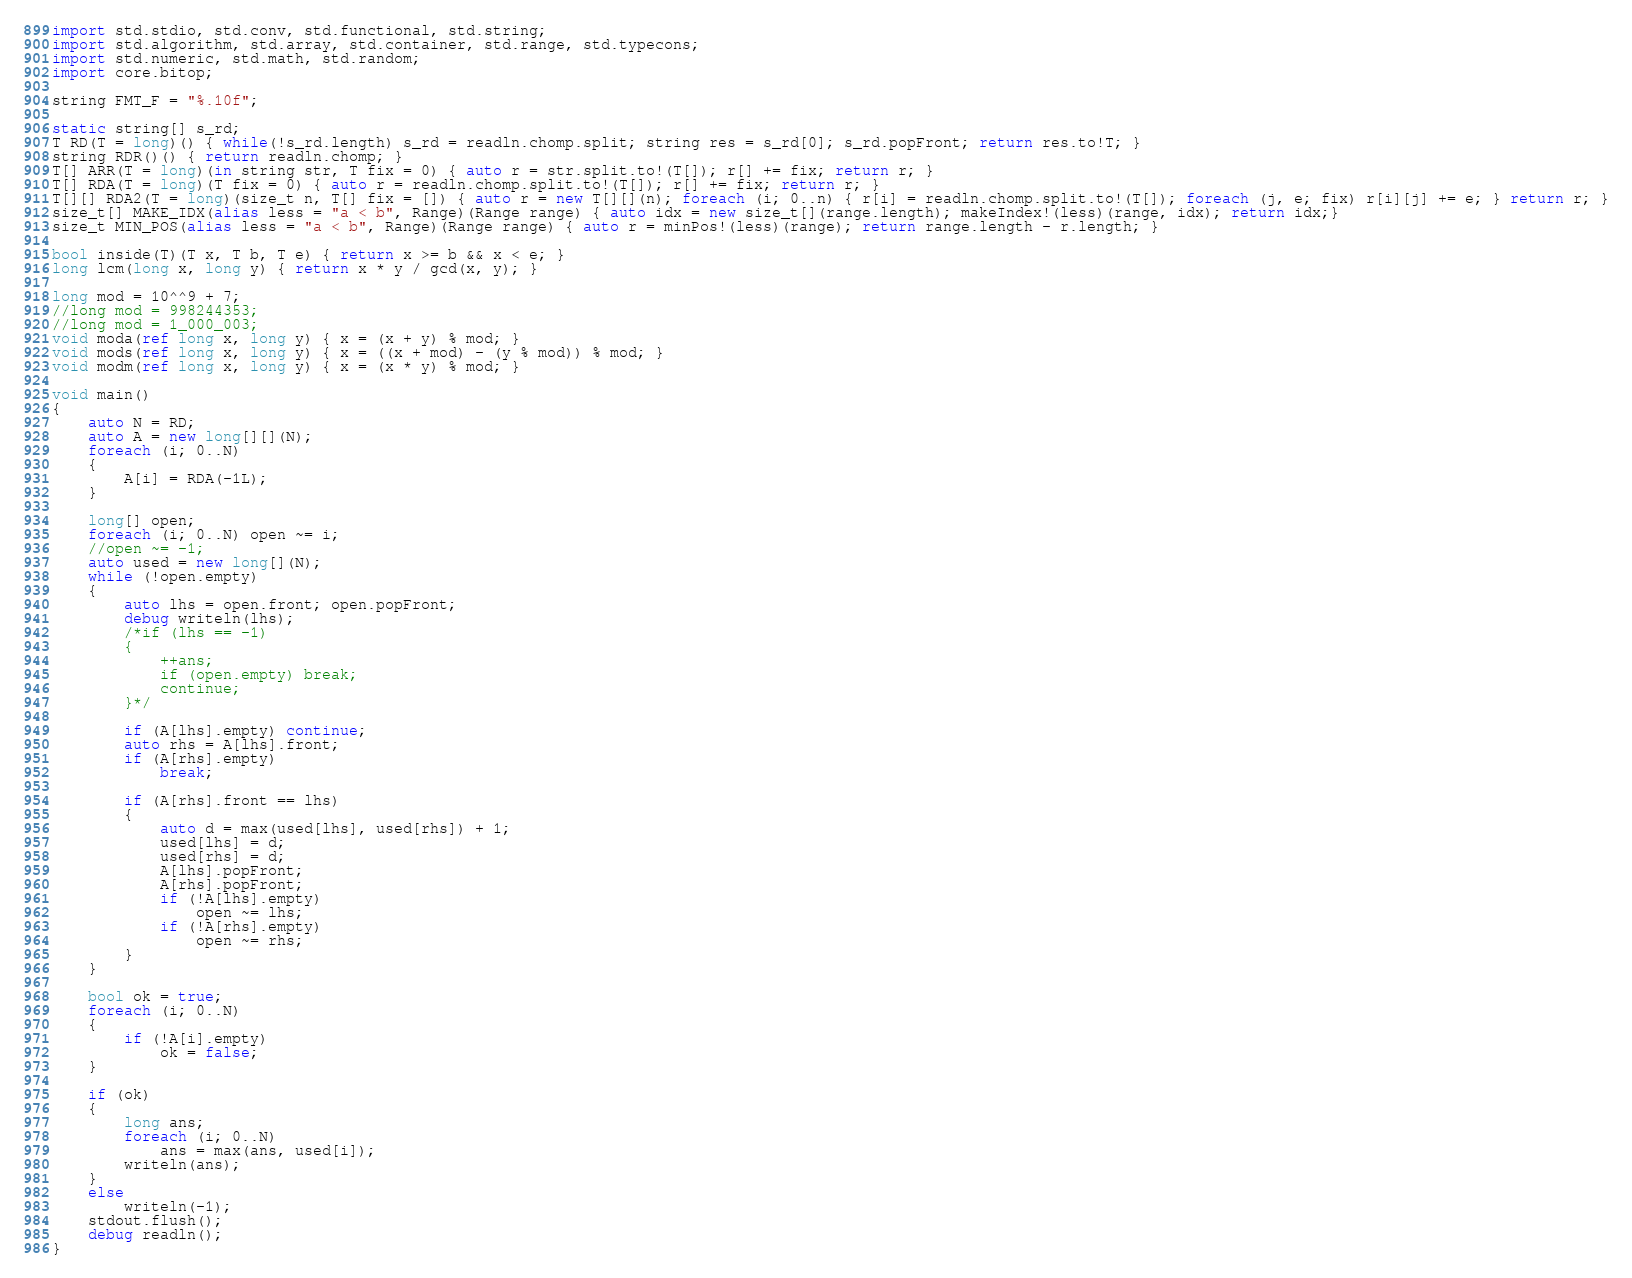<code> <loc_0><loc_0><loc_500><loc_500><_D_>import std.stdio, std.conv, std.functional, std.string;
import std.algorithm, std.array, std.container, std.range, std.typecons;
import std.numeric, std.math, std.random;
import core.bitop;

string FMT_F = "%.10f";

static string[] s_rd;
T RD(T = long)() { while(!s_rd.length) s_rd = readln.chomp.split; string res = s_rd[0]; s_rd.popFront; return res.to!T; }
string RDR()() { return readln.chomp; }
T[] ARR(T = long)(in string str, T fix = 0) { auto r = str.split.to!(T[]); r[] += fix; return r; }
T[] RDA(T = long)(T fix = 0) { auto r = readln.chomp.split.to!(T[]); r[] += fix; return r; }
T[][] RDA2(T = long)(size_t n, T[] fix = []) { auto r = new T[][](n); foreach (i; 0..n) { r[i] = readln.chomp.split.to!(T[]); foreach (j, e; fix) r[i][j] += e; } return r; }
size_t[] MAKE_IDX(alias less = "a < b", Range)(Range range) { auto idx = new size_t[](range.length); makeIndex!(less)(range, idx); return idx;}
size_t MIN_POS(alias less = "a < b", Range)(Range range) { auto r = minPos!(less)(range); return range.length - r.length; }

bool inside(T)(T x, T b, T e) { return x >= b && x < e; }
long lcm(long x, long y) { return x * y / gcd(x, y); }

long mod = 10^^9 + 7;
//long mod = 998244353;
//long mod = 1_000_003;
void moda(ref long x, long y) { x = (x + y) % mod; }
void mods(ref long x, long y) { x = ((x + mod) - (y % mod)) % mod; }
void modm(ref long x, long y) { x = (x * y) % mod; }

void main()
{
	auto N = RD;
	auto A = new long[][](N);
	foreach (i; 0..N)
	{
		A[i] = RDA(-1L);
	}

	long[] open;
	foreach (i; 0..N) open ~= i;
	//open ~= -1;
	auto used = new long[](N);
	while (!open.empty)
	{
		auto lhs = open.front; open.popFront;
		debug writeln(lhs);
		/*if (lhs == -1)
		{
			++ans;
			if (open.empty) break;
			continue;
		}*/
		
		if (A[lhs].empty) continue;
		auto rhs = A[lhs].front;
		if (A[rhs].empty)
			break;

		if (A[rhs].front == lhs)
		{
			auto d = max(used[lhs], used[rhs]) + 1;
			used[lhs] = d;
			used[rhs] = d;
			A[lhs].popFront;
			A[rhs].popFront;
			if (!A[lhs].empty)
				open ~= lhs;
			if (!A[rhs].empty)
				open ~= rhs;
		}
	}

	bool ok = true;
	foreach (i; 0..N)
	{
		if (!A[i].empty)
			ok = false;
	}

	if (ok)
	{
		long ans;
		foreach (i; 0..N)
			ans = max(ans, used[i]);
		writeln(ans);
	}
	else
		writeln(-1);
	stdout.flush();
	debug readln();
}</code> 